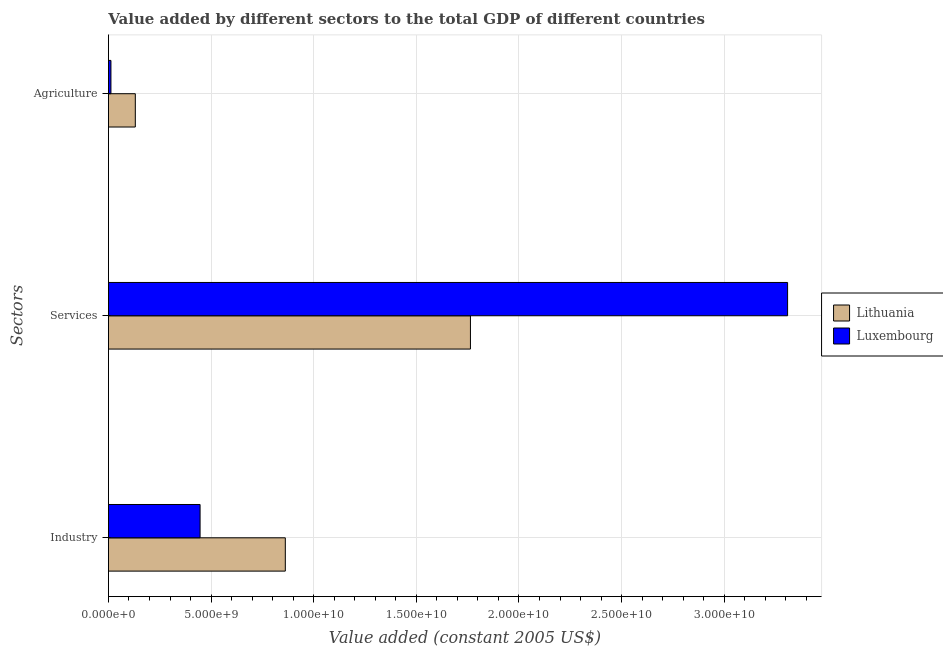How many groups of bars are there?
Keep it short and to the point. 3. Are the number of bars per tick equal to the number of legend labels?
Keep it short and to the point. Yes. How many bars are there on the 2nd tick from the bottom?
Your answer should be very brief. 2. What is the label of the 2nd group of bars from the top?
Provide a short and direct response. Services. What is the value added by agricultural sector in Lithuania?
Make the answer very short. 1.31e+09. Across all countries, what is the maximum value added by agricultural sector?
Your answer should be very brief. 1.31e+09. Across all countries, what is the minimum value added by services?
Keep it short and to the point. 1.76e+1. In which country was the value added by services maximum?
Your response must be concise. Luxembourg. In which country was the value added by agricultural sector minimum?
Offer a very short reply. Luxembourg. What is the total value added by services in the graph?
Your answer should be compact. 5.07e+1. What is the difference between the value added by agricultural sector in Lithuania and that in Luxembourg?
Provide a succinct answer. 1.19e+09. What is the difference between the value added by services in Lithuania and the value added by agricultural sector in Luxembourg?
Keep it short and to the point. 1.75e+1. What is the average value added by services per country?
Your answer should be compact. 2.54e+1. What is the difference between the value added by agricultural sector and value added by services in Lithuania?
Your response must be concise. -1.63e+1. In how many countries, is the value added by services greater than 23000000000 US$?
Your response must be concise. 1. What is the ratio of the value added by services in Lithuania to that in Luxembourg?
Make the answer very short. 0.53. Is the difference between the value added by agricultural sector in Luxembourg and Lithuania greater than the difference between the value added by services in Luxembourg and Lithuania?
Offer a terse response. No. What is the difference between the highest and the second highest value added by services?
Keep it short and to the point. 1.54e+1. What is the difference between the highest and the lowest value added by agricultural sector?
Make the answer very short. 1.19e+09. Is the sum of the value added by services in Luxembourg and Lithuania greater than the maximum value added by industrial sector across all countries?
Ensure brevity in your answer.  Yes. What does the 1st bar from the top in Industry represents?
Offer a very short reply. Luxembourg. What does the 1st bar from the bottom in Services represents?
Ensure brevity in your answer.  Lithuania. Are all the bars in the graph horizontal?
Make the answer very short. Yes. What is the difference between two consecutive major ticks on the X-axis?
Provide a succinct answer. 5.00e+09. How many legend labels are there?
Provide a short and direct response. 2. What is the title of the graph?
Your answer should be compact. Value added by different sectors to the total GDP of different countries. What is the label or title of the X-axis?
Offer a very short reply. Value added (constant 2005 US$). What is the label or title of the Y-axis?
Your answer should be compact. Sectors. What is the Value added (constant 2005 US$) in Lithuania in Industry?
Keep it short and to the point. 8.62e+09. What is the Value added (constant 2005 US$) in Luxembourg in Industry?
Your response must be concise. 4.46e+09. What is the Value added (constant 2005 US$) of Lithuania in Services?
Ensure brevity in your answer.  1.76e+1. What is the Value added (constant 2005 US$) of Luxembourg in Services?
Provide a short and direct response. 3.31e+1. What is the Value added (constant 2005 US$) of Lithuania in Agriculture?
Your answer should be compact. 1.31e+09. What is the Value added (constant 2005 US$) of Luxembourg in Agriculture?
Ensure brevity in your answer.  1.22e+08. Across all Sectors, what is the maximum Value added (constant 2005 US$) in Lithuania?
Provide a short and direct response. 1.76e+1. Across all Sectors, what is the maximum Value added (constant 2005 US$) in Luxembourg?
Offer a terse response. 3.31e+1. Across all Sectors, what is the minimum Value added (constant 2005 US$) of Lithuania?
Your answer should be very brief. 1.31e+09. Across all Sectors, what is the minimum Value added (constant 2005 US$) of Luxembourg?
Your answer should be compact. 1.22e+08. What is the total Value added (constant 2005 US$) in Lithuania in the graph?
Give a very brief answer. 2.76e+1. What is the total Value added (constant 2005 US$) in Luxembourg in the graph?
Offer a very short reply. 3.77e+1. What is the difference between the Value added (constant 2005 US$) in Lithuania in Industry and that in Services?
Give a very brief answer. -9.02e+09. What is the difference between the Value added (constant 2005 US$) of Luxembourg in Industry and that in Services?
Ensure brevity in your answer.  -2.86e+1. What is the difference between the Value added (constant 2005 US$) of Lithuania in Industry and that in Agriculture?
Provide a short and direct response. 7.31e+09. What is the difference between the Value added (constant 2005 US$) of Luxembourg in Industry and that in Agriculture?
Ensure brevity in your answer.  4.34e+09. What is the difference between the Value added (constant 2005 US$) in Lithuania in Services and that in Agriculture?
Provide a short and direct response. 1.63e+1. What is the difference between the Value added (constant 2005 US$) of Luxembourg in Services and that in Agriculture?
Give a very brief answer. 3.30e+1. What is the difference between the Value added (constant 2005 US$) of Lithuania in Industry and the Value added (constant 2005 US$) of Luxembourg in Services?
Keep it short and to the point. -2.45e+1. What is the difference between the Value added (constant 2005 US$) in Lithuania in Industry and the Value added (constant 2005 US$) in Luxembourg in Agriculture?
Make the answer very short. 8.49e+09. What is the difference between the Value added (constant 2005 US$) of Lithuania in Services and the Value added (constant 2005 US$) of Luxembourg in Agriculture?
Provide a short and direct response. 1.75e+1. What is the average Value added (constant 2005 US$) in Lithuania per Sectors?
Your response must be concise. 9.19e+09. What is the average Value added (constant 2005 US$) of Luxembourg per Sectors?
Offer a very short reply. 1.26e+1. What is the difference between the Value added (constant 2005 US$) in Lithuania and Value added (constant 2005 US$) in Luxembourg in Industry?
Make the answer very short. 4.15e+09. What is the difference between the Value added (constant 2005 US$) of Lithuania and Value added (constant 2005 US$) of Luxembourg in Services?
Offer a terse response. -1.54e+1. What is the difference between the Value added (constant 2005 US$) of Lithuania and Value added (constant 2005 US$) of Luxembourg in Agriculture?
Offer a very short reply. 1.19e+09. What is the ratio of the Value added (constant 2005 US$) of Lithuania in Industry to that in Services?
Your answer should be very brief. 0.49. What is the ratio of the Value added (constant 2005 US$) in Luxembourg in Industry to that in Services?
Your answer should be very brief. 0.13. What is the ratio of the Value added (constant 2005 US$) of Lithuania in Industry to that in Agriculture?
Your answer should be very brief. 6.58. What is the ratio of the Value added (constant 2005 US$) in Luxembourg in Industry to that in Agriculture?
Keep it short and to the point. 36.55. What is the ratio of the Value added (constant 2005 US$) of Lithuania in Services to that in Agriculture?
Provide a short and direct response. 13.47. What is the ratio of the Value added (constant 2005 US$) of Luxembourg in Services to that in Agriculture?
Your answer should be compact. 270.83. What is the difference between the highest and the second highest Value added (constant 2005 US$) in Lithuania?
Offer a terse response. 9.02e+09. What is the difference between the highest and the second highest Value added (constant 2005 US$) of Luxembourg?
Keep it short and to the point. 2.86e+1. What is the difference between the highest and the lowest Value added (constant 2005 US$) in Lithuania?
Provide a short and direct response. 1.63e+1. What is the difference between the highest and the lowest Value added (constant 2005 US$) of Luxembourg?
Offer a terse response. 3.30e+1. 